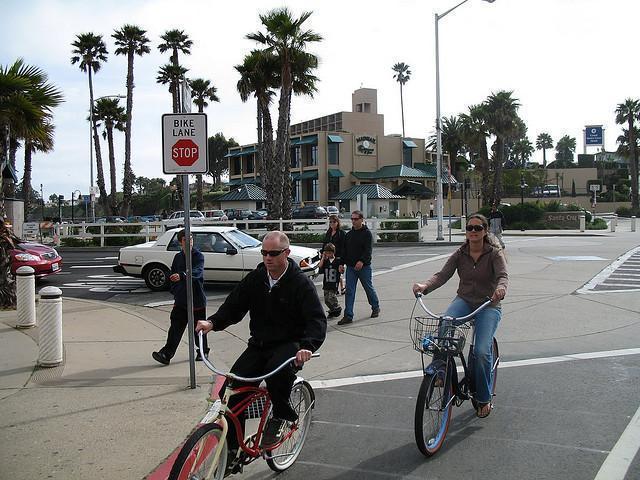What kind of sign is shown?
Pick the right solution, then justify: 'Answer: answer
Rationale: rationale.'
Options: Traffic, name, brand, price. Answer: traffic.
Rationale: You can tell by the shape and the wording as to what type of sign is being shown. 